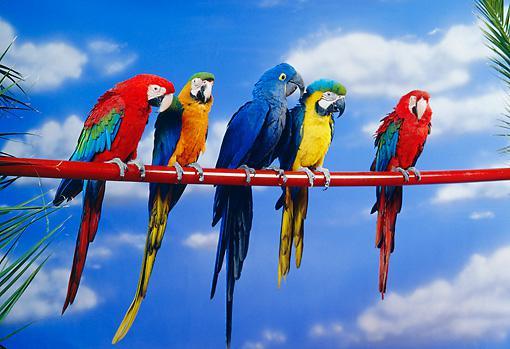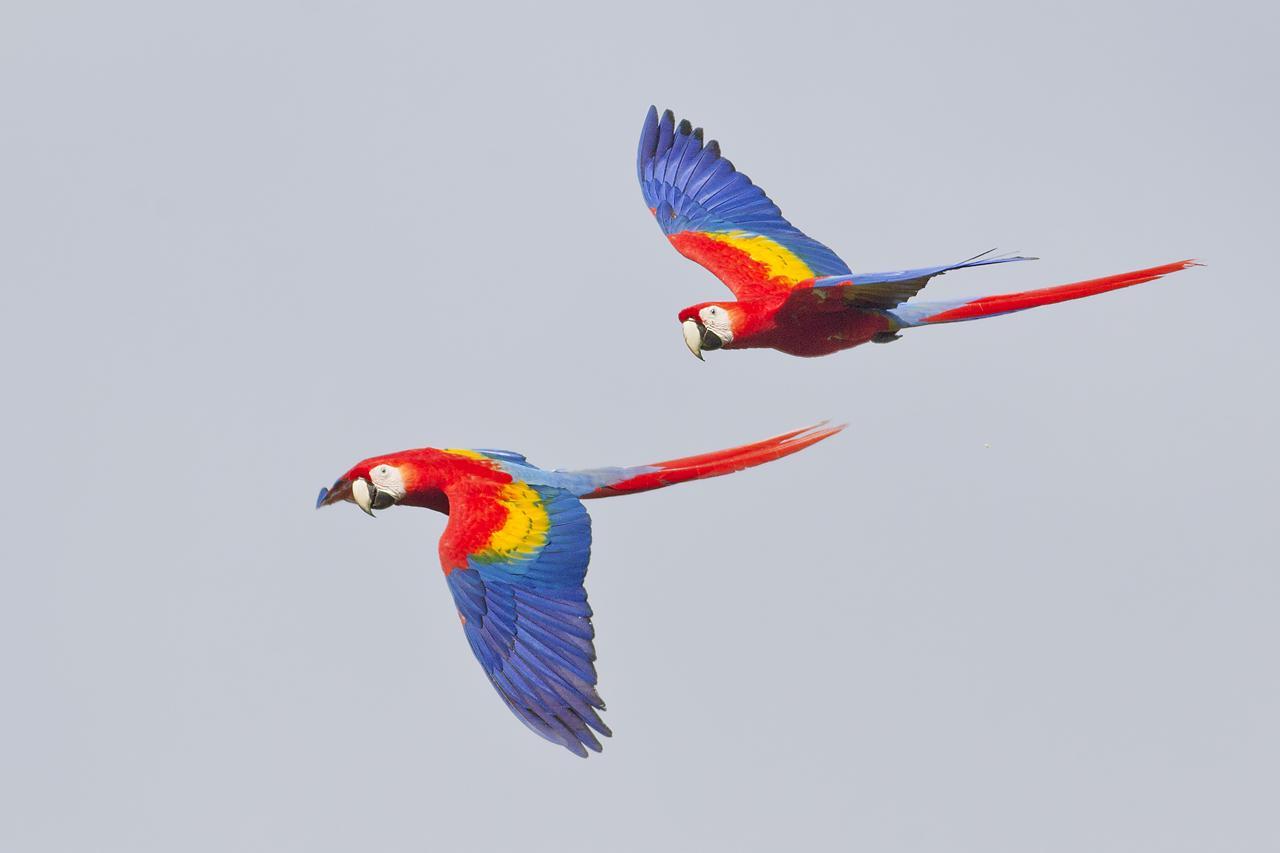The first image is the image on the left, the second image is the image on the right. Evaluate the accuracy of this statement regarding the images: "There is at least one parrot perched on something rather than in flight". Is it true? Answer yes or no. Yes. 